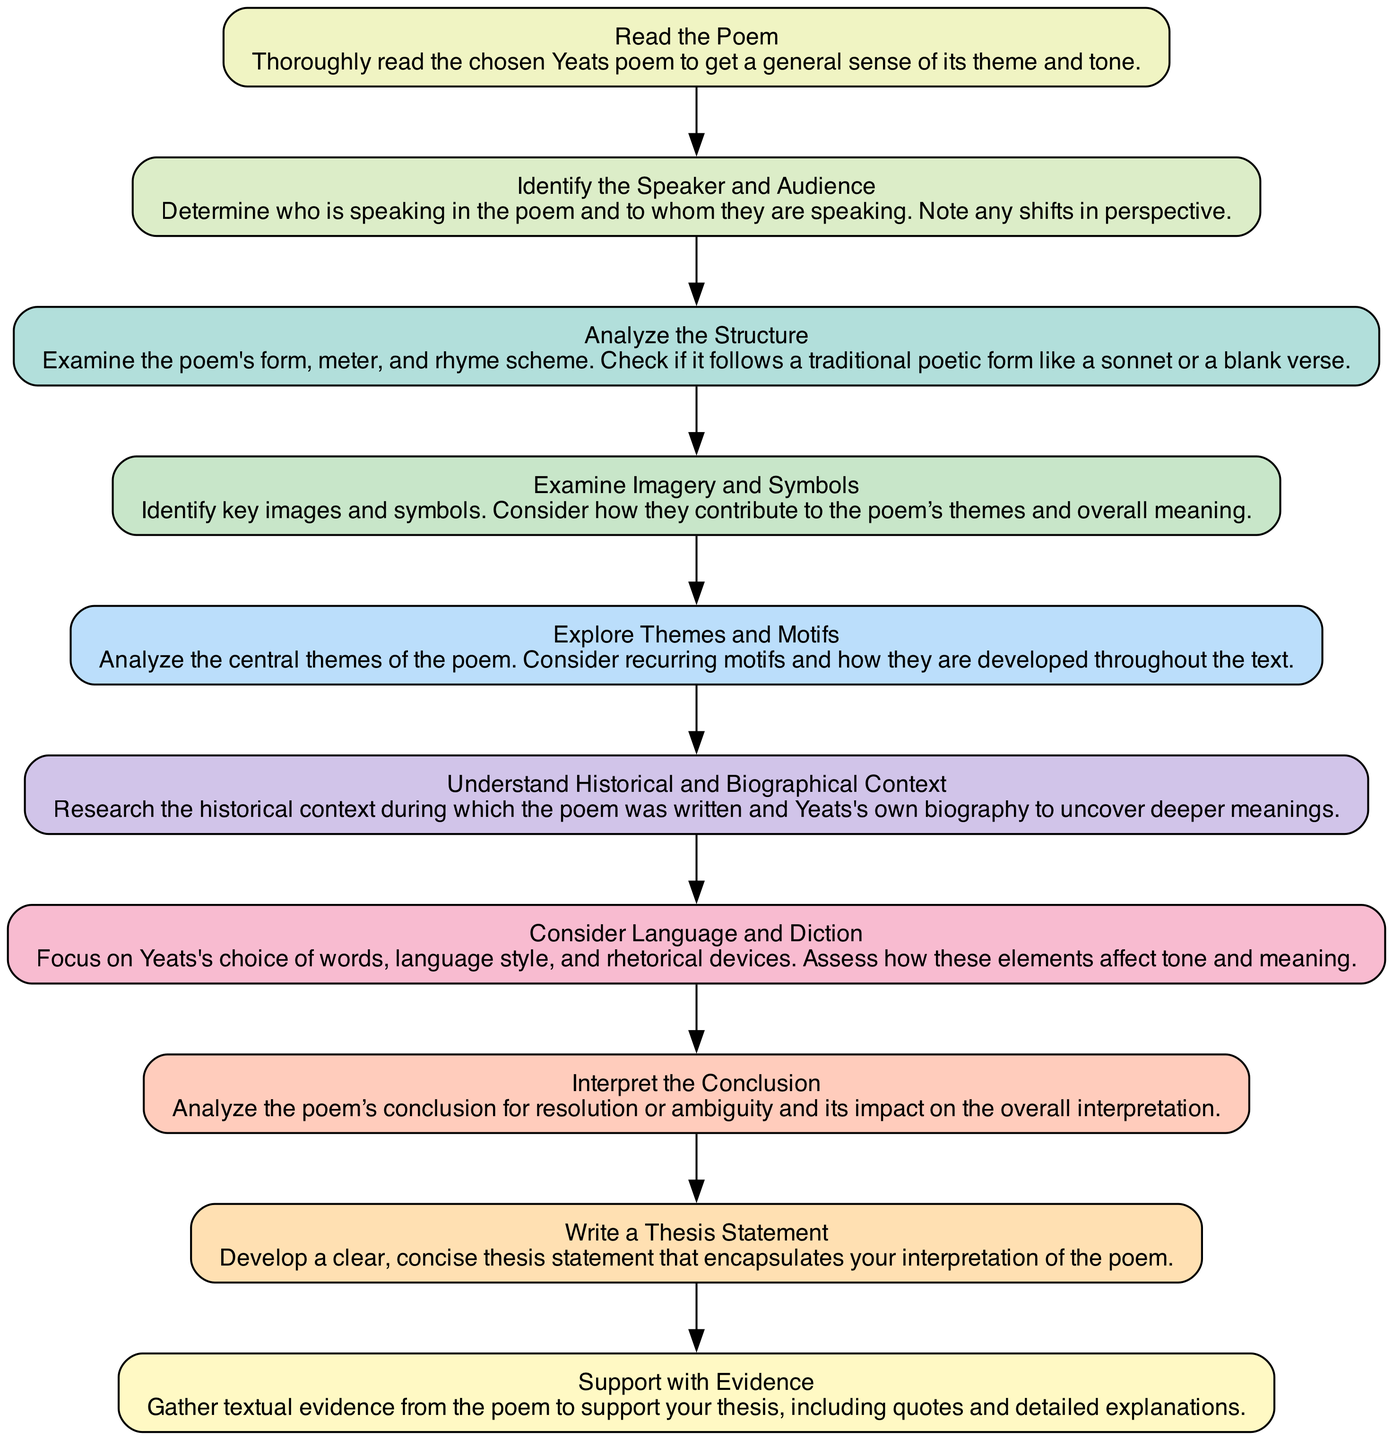What is the first step in analyzing a Yeats poem? The diagram shows that the first step is to "Read the Poem." This is the introductory action that leads to further analysis.
Answer: Read the Poem How many nodes are there in the diagram? The diagram contains ten nodes, each representing a step in analyzing the poem.
Answer: 10 What is the last action illustrated in the flow chart? The final action node is "Support with Evidence," which indicates the conclusion of the analysis process.
Answer: Support with Evidence Which step comes after "Explore Themes and Motifs"? Following "Explore Themes and Motifs," the next step in the flow is "Understand Historical and Biographical Context." This means that after examining themes, the analysis shifts to the context.
Answer: Understand Historical and Biographical Context What does the node "Consider Language and Diction" involve? The node indicates a focus on the words, language style, and rhetorical devices chosen by Yeats, assessing how these elements contribute to the poem's tone and meaning.
Answer: Focus on Yeats's choice of words What is the relationship between "Identify the Speaker and Audience" and "Analyze the Structure"? "Identify the Speaker and Audience" is an initial step leading to "Analyze the Structure." It establishes the speaker's perspective, which can influence structural analysis.
Answer: Initial step leading to structural analysis Which two steps are directly connected prior to writing the thesis? The steps "Interpret the Conclusion" and "Write a Thesis Statement" are directly connected, as understanding the conclusion informs the development of the thesis.
Answer: Interpret the Conclusion and Write a Thesis Statement In analyzing imagery, which node should you consult after "Examine Imagery and Symbols"? After "Examine Imagery and Symbols," you should consult "Explore Themes and Motifs," as understanding the imagery helps in analyzing the themes.
Answer: Explore Themes and Motifs What category do “Analyze the Structure” and “Consider Language and Diction” fall under? Both nodes fall under the detailed analyses steps in discussing the poem's elements, focusing on its form and language respectively.
Answer: Detailed analyses steps 